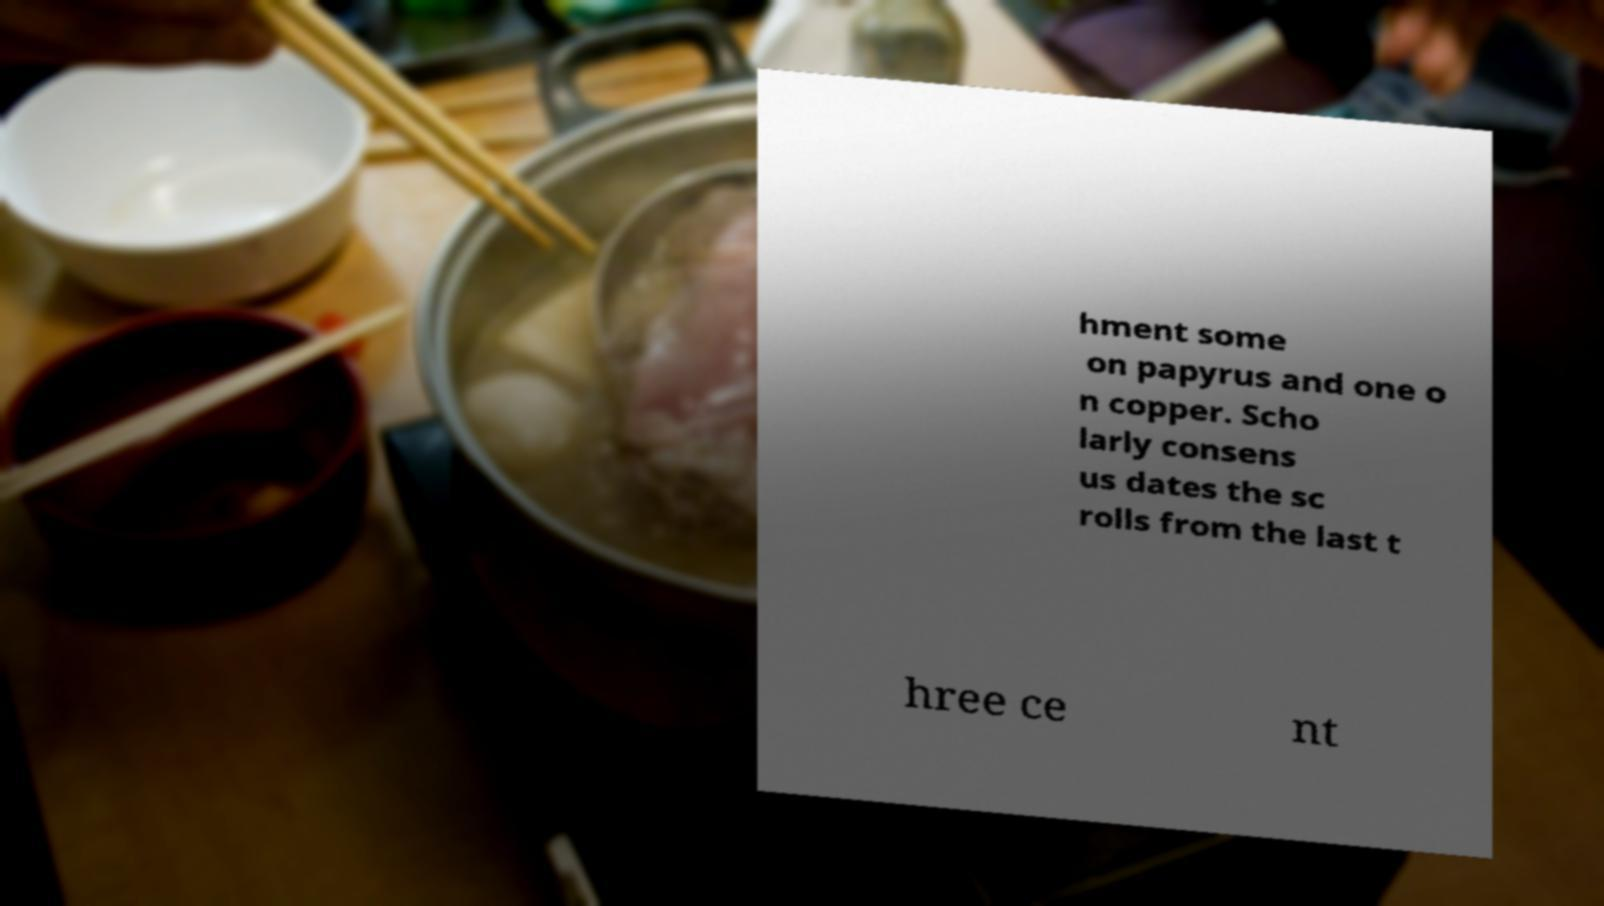Could you extract and type out the text from this image? hment some on papyrus and one o n copper. Scho larly consens us dates the sc rolls from the last t hree ce nt 